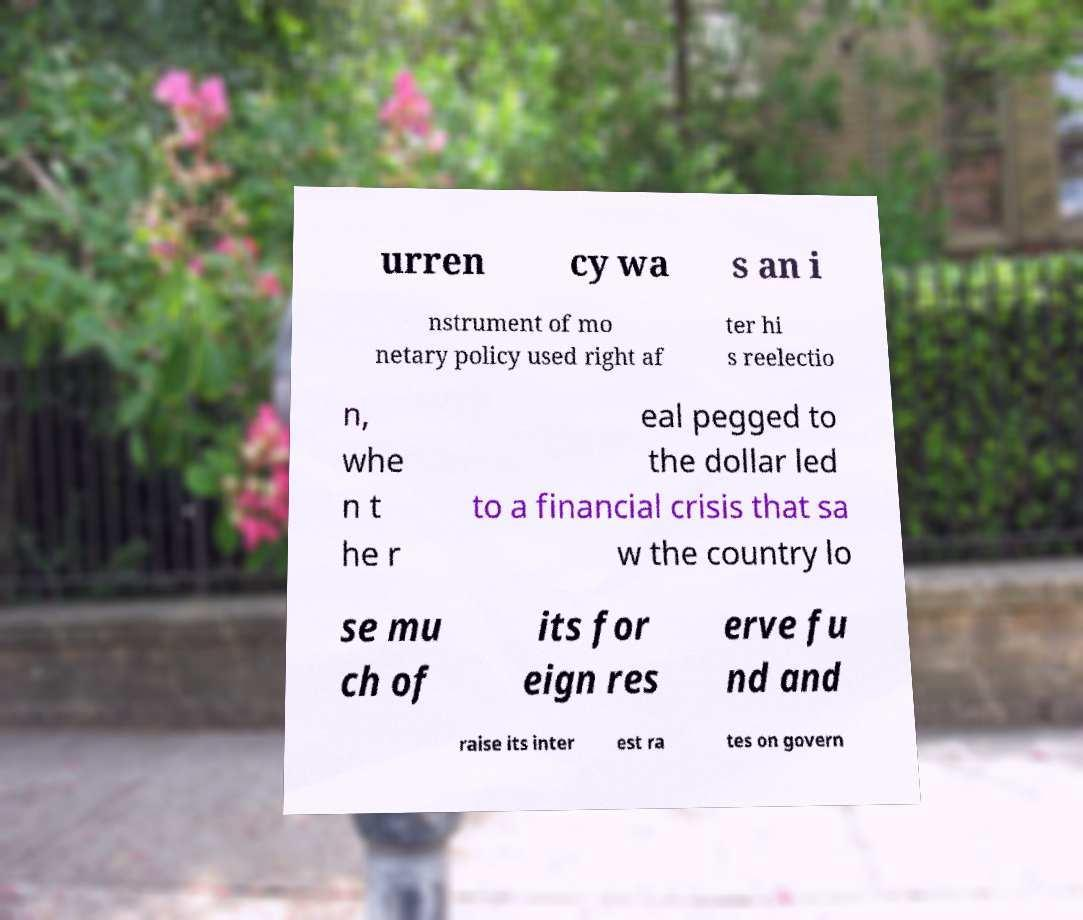For documentation purposes, I need the text within this image transcribed. Could you provide that? urren cy wa s an i nstrument of mo netary policy used right af ter hi s reelectio n, whe n t he r eal pegged to the dollar led to a financial crisis that sa w the country lo se mu ch of its for eign res erve fu nd and raise its inter est ra tes on govern 